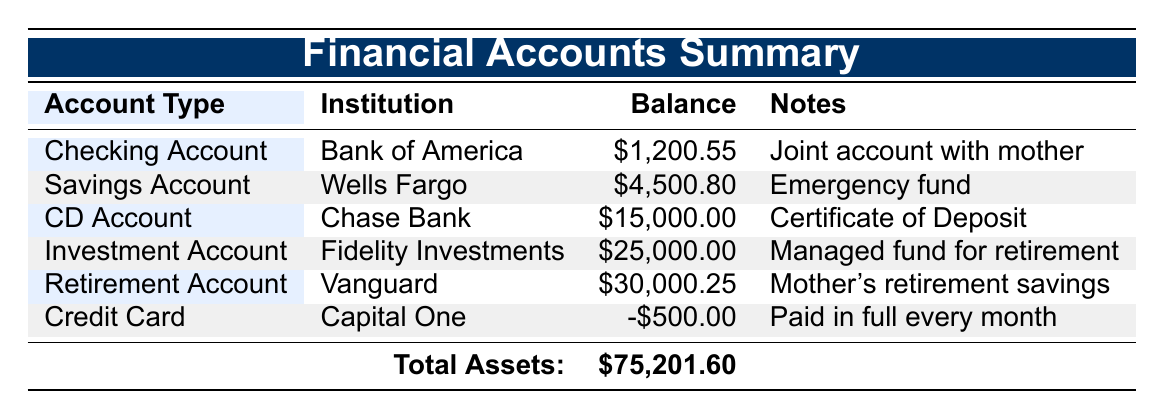What is the balance of the Checking Account? The balance can be found directly in the table under the Checking Account entry, which states it is 1200.55.
Answer: 1200.55 What is the total balance of all the financial accounts? To find the total balance, sum all the account balances: 1200.55 + 4500.80 + 15000.00 + 25000.00 + 30000.25 - 500.00 = 75201.60.
Answer: 75201.60 Is there any account with a negative balance? By examining the table, only the Credit Card shows a balance of -500.00, indicating that it is in the negative.
Answer: Yes What is the maturity date of the CD Account? The maturity date is specified in the table for the CD Account managed by Chase Bank, which states it is 2026-03-01.
Answer: 2026-03-01 How much does the Savings Account earn monthly compared to the Checking Account? The Checking Account incurs a monthly fee of 12.00, while the Savings Account has no monthly fees, indicating a difference of 12.00 (12.00 - 0.00).
Answer: 12.00 What type of retirement plan is associated with the Retirement Account? The table shows that the Retirement Account from Vanguard is identified as a Roth IRA.
Answer: Roth IRA Which account has the highest balance, and what is that balance? Comparing all the balances in the table, the Retirement Account with Vanguard has the highest balance of 30000.25.
Answer: 30000.25 How many accounts were opened prior to 2015? The relevant accounts are the Savings Account (opened in 2010) and the Retirement Account (opened in 2016), giving a total of 2 accounts opened before 2015.
Answer: 2 What are the total fees incurred per month for maintaining all accounts? The only account with a fee is the Checking Account which charges 12.00 monthly. The Savings account has no fees, and the others don’t mention any, so the total monthly fees would be 12.00.
Answer: 12.00 How does the interest rate of the CD Account compare to the balance of the Investment Account? The table indicates an interest rate of 1.5 for the CD Account with a balance of 15000.00, while the Investment Account has a balance of 25000.00. The CD Account does not directly correlate to the Investment Account's balance, as it depends on investment returns versus fixed interest.
Answer: It is lower in interest 